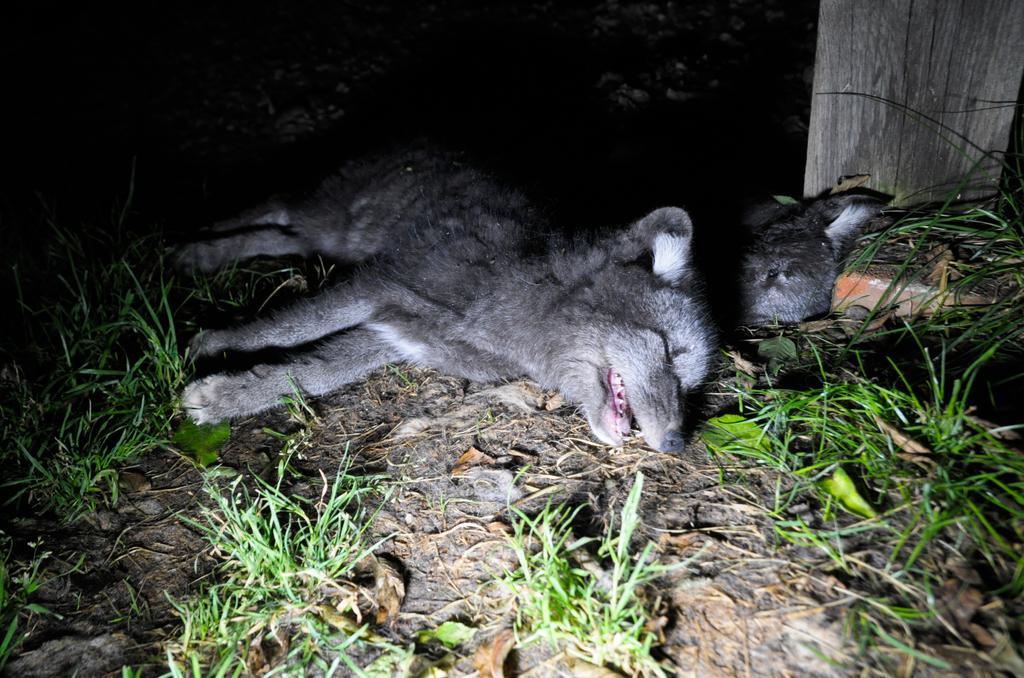Please provide a concise description of this image. At the bottom of the image there is a ground with grass. And on the grass there are two animals sleeping. And also there is a wooden item. 